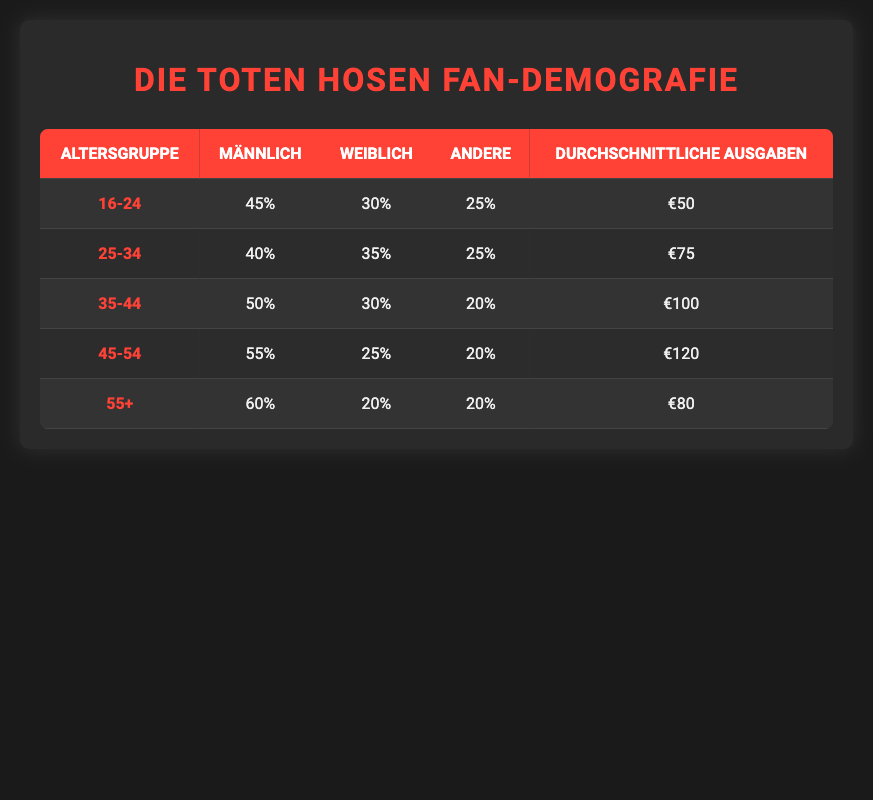What percentage of fans aged 45-54 are male? In the table, under the age group 45-54, the male percentage is listed as 55.
Answer: 55 What is the average spending of fans in the age group 35-44? The table shows that the average spending for the age group 35-44 is 100.
Answer: 100 Which age group has the highest percentage of female fans? By examining the table, the age group 25-34 has a female percentage of 35, which is the highest among all groups.
Answer: 25-34 Is it true that the percentage of other gender fans decreases in the age group 55+ compared to the age group 16-24? In the age group 55+, the percentage of other gender fans is 20, and in the age group 16-24, it is 25. Therefore, the percentage indeed decreases.
Answer: Yes What is the combined average spending of fans in the age groups 16-24 and 25-34? The average spending for the age group 16-24 is 50 and for 25-34 is 75. Adding these values gives 50 + 75 = 125.
Answer: 125 Which age group has the highest average spending? The table shows that the age group 45-54 has an average spending of 120, which is the highest among all provided age groups.
Answer: 45-54 What is the percentage of male fans aged 55 and older? Referring to the table, the male percentage in the age group 55+ is 60.
Answer: 60 What is the difference in average spending between fans aged 45-54 and those aged 35-44? The average spending for fans aged 45-54 is 120, and for 35-44 it is 100. The difference is calculated as 120 - 100 = 20.
Answer: 20 What percentage of fans in the age group 35-44 are not male? The male percentage in the age group 35-44 is 50. Therefore, 100 - 50 = 50 percent of fans in this group are not male.
Answer: 50 